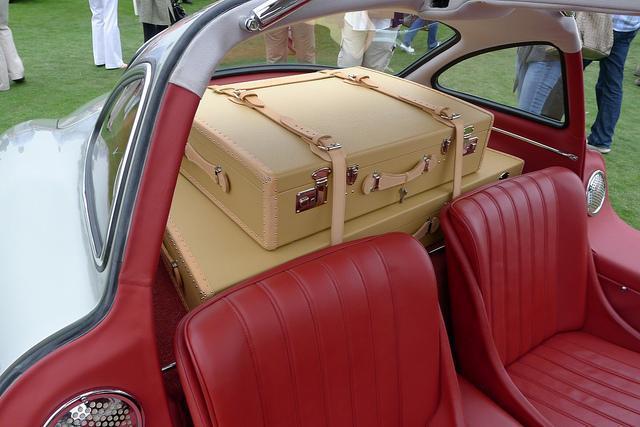How many people are visible?
Give a very brief answer. 3. How many chairs are there?
Give a very brief answer. 2. How many suitcases are visible?
Give a very brief answer. 2. How many giraffes are in the photo?
Give a very brief answer. 0. 